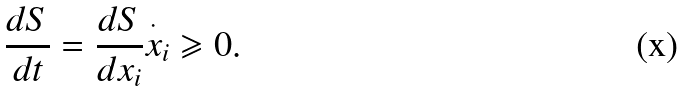Convert formula to latex. <formula><loc_0><loc_0><loc_500><loc_500>\frac { d S } { d t } = \frac { d S } { d x _ { i } } \overset { \cdot } { x } _ { i } \geqslant 0 .</formula> 